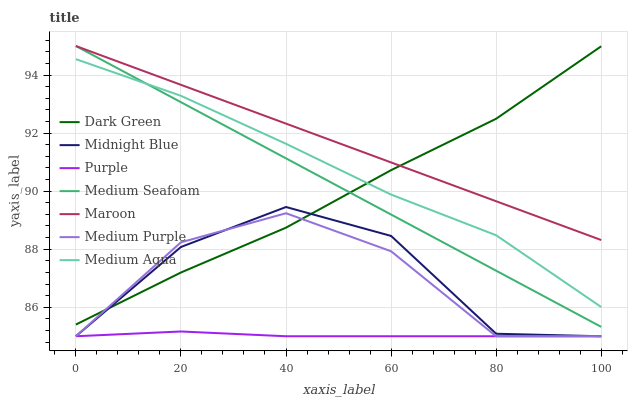Does Purple have the minimum area under the curve?
Answer yes or no. Yes. Does Maroon have the maximum area under the curve?
Answer yes or no. Yes. Does Maroon have the minimum area under the curve?
Answer yes or no. No. Does Purple have the maximum area under the curve?
Answer yes or no. No. Is Maroon the smoothest?
Answer yes or no. Yes. Is Midnight Blue the roughest?
Answer yes or no. Yes. Is Purple the smoothest?
Answer yes or no. No. Is Purple the roughest?
Answer yes or no. No. Does Maroon have the lowest value?
Answer yes or no. No. Does Medium Seafoam have the highest value?
Answer yes or no. Yes. Does Purple have the highest value?
Answer yes or no. No. Is Purple less than Medium Seafoam?
Answer yes or no. Yes. Is Medium Aqua greater than Purple?
Answer yes or no. Yes. Does Purple intersect Medium Seafoam?
Answer yes or no. No. 